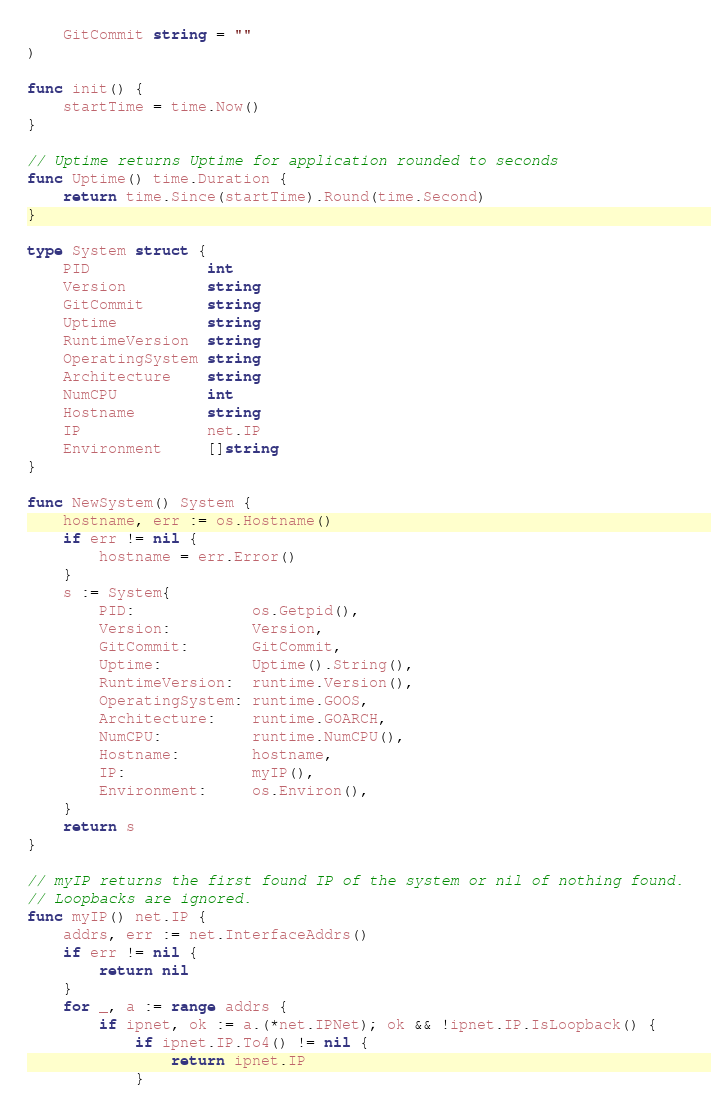<code> <loc_0><loc_0><loc_500><loc_500><_Go_>	GitCommit string = ""
)

func init() {
	startTime = time.Now()
}

// Uptime returns Uptime for application rounded to seconds
func Uptime() time.Duration {
	return time.Since(startTime).Round(time.Second)
}

type System struct {
	PID             int
	Version         string
	GitCommit       string
	Uptime          string
	RuntimeVersion  string
	OperatingSystem string
	Architecture    string
	NumCPU          int
	Hostname        string
	IP              net.IP
	Environment     []string
}

func NewSystem() System {
	hostname, err := os.Hostname()
	if err != nil {
		hostname = err.Error()
	}
	s := System{
		PID:             os.Getpid(),
		Version:         Version,
		GitCommit:       GitCommit,
		Uptime:          Uptime().String(),
		RuntimeVersion:  runtime.Version(),
		OperatingSystem: runtime.GOOS,
		Architecture:    runtime.GOARCH,
		NumCPU:          runtime.NumCPU(),
		Hostname:        hostname,
		IP:              myIP(),
		Environment:     os.Environ(),
	}
	return s
}

// myIP returns the first found IP of the system or nil of nothing found.
// Loopbacks are ignored.
func myIP() net.IP {
	addrs, err := net.InterfaceAddrs()
	if err != nil {
		return nil
	}
	for _, a := range addrs {
		if ipnet, ok := a.(*net.IPNet); ok && !ipnet.IP.IsLoopback() {
			if ipnet.IP.To4() != nil {
				return ipnet.IP
			}</code> 